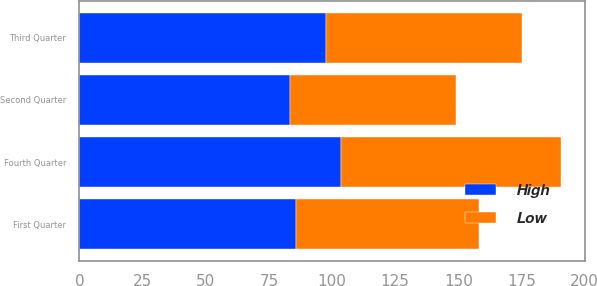Convert chart. <chart><loc_0><loc_0><loc_500><loc_500><stacked_bar_chart><ecel><fcel>Fourth Quarter<fcel>Third Quarter<fcel>Second Quarter<fcel>First Quarter<nl><fcel>High<fcel>103.4<fcel>97.6<fcel>83.32<fcel>85.56<nl><fcel>Low<fcel>87.08<fcel>77.74<fcel>65.91<fcel>72.79<nl></chart> 